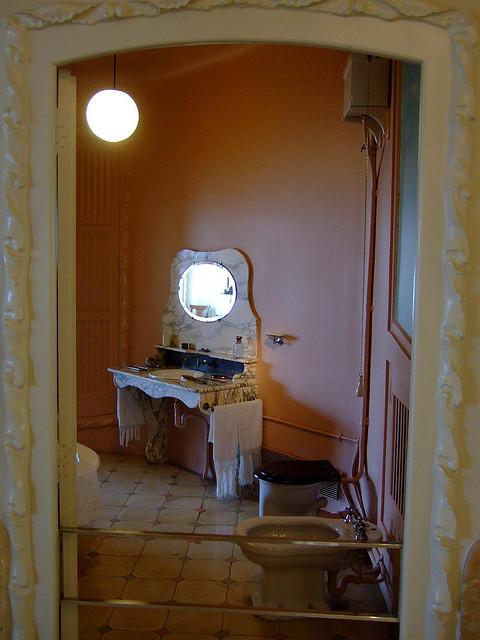What is the black-lidded object next to the vanity?
Answer briefly. Toilet. What shape is the lamp in the room?
Keep it brief. Round. What room is this?
Write a very short answer. Bathroom. 